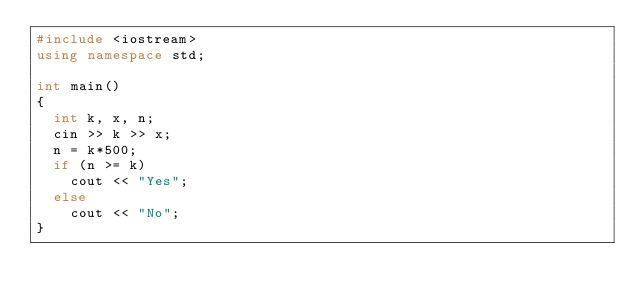<code> <loc_0><loc_0><loc_500><loc_500><_C++_>#include <iostream>
using namespace std;

int main()
{
	int k, x, n;
	cin >> k >> x;
	n = k*500;
	if (n >= k)
		cout << "Yes";
	else
		cout << "No";
}</code> 